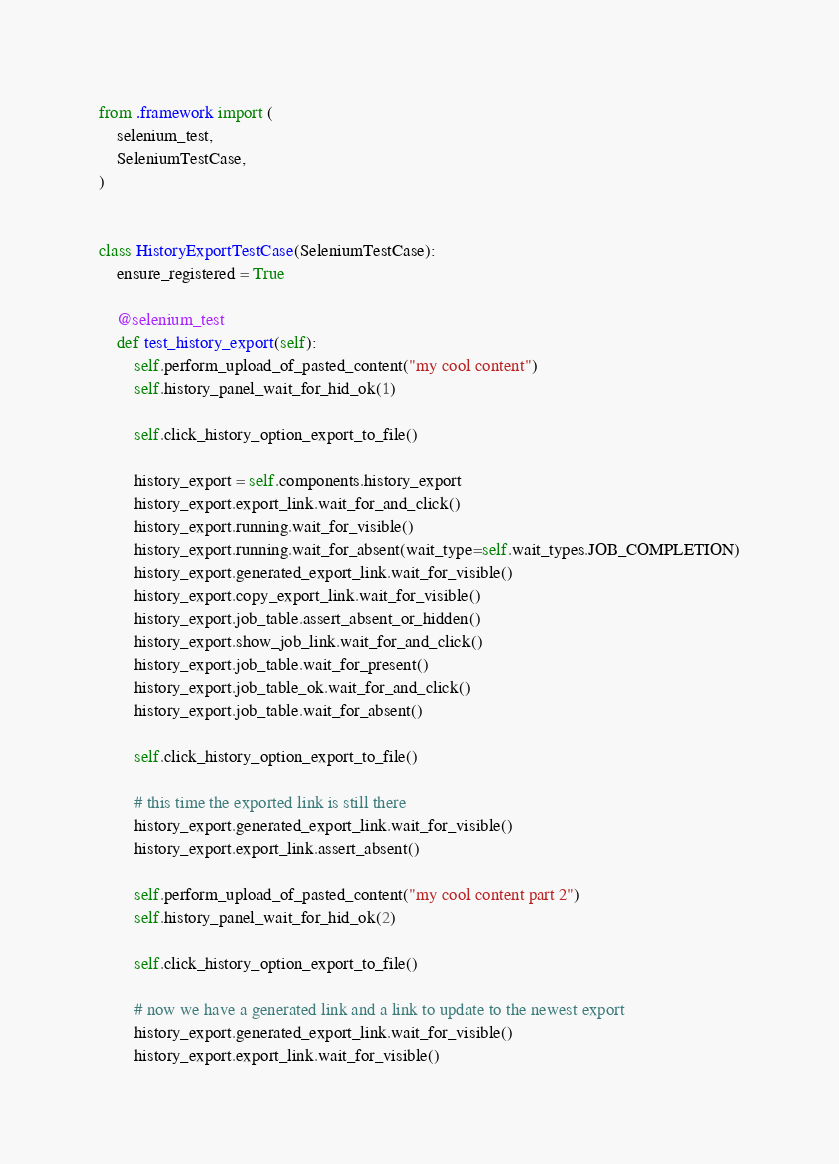<code> <loc_0><loc_0><loc_500><loc_500><_Python_>from .framework import (
    selenium_test,
    SeleniumTestCase,
)


class HistoryExportTestCase(SeleniumTestCase):
    ensure_registered = True

    @selenium_test
    def test_history_export(self):
        self.perform_upload_of_pasted_content("my cool content")
        self.history_panel_wait_for_hid_ok(1)

        self.click_history_option_export_to_file()

        history_export = self.components.history_export
        history_export.export_link.wait_for_and_click()
        history_export.running.wait_for_visible()
        history_export.running.wait_for_absent(wait_type=self.wait_types.JOB_COMPLETION)
        history_export.generated_export_link.wait_for_visible()
        history_export.copy_export_link.wait_for_visible()
        history_export.job_table.assert_absent_or_hidden()
        history_export.show_job_link.wait_for_and_click()
        history_export.job_table.wait_for_present()
        history_export.job_table_ok.wait_for_and_click()
        history_export.job_table.wait_for_absent()

        self.click_history_option_export_to_file()

        # this time the exported link is still there
        history_export.generated_export_link.wait_for_visible()
        history_export.export_link.assert_absent()

        self.perform_upload_of_pasted_content("my cool content part 2")
        self.history_panel_wait_for_hid_ok(2)

        self.click_history_option_export_to_file()

        # now we have a generated link and a link to update to the newest export
        history_export.generated_export_link.wait_for_visible()
        history_export.export_link.wait_for_visible()
</code> 